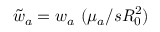Convert formula to latex. <formula><loc_0><loc_0><loc_500><loc_500>\tilde { w } _ { a } = w _ { a } \ ( \mu _ { a } / s R _ { 0 } ^ { 2 } )</formula> 